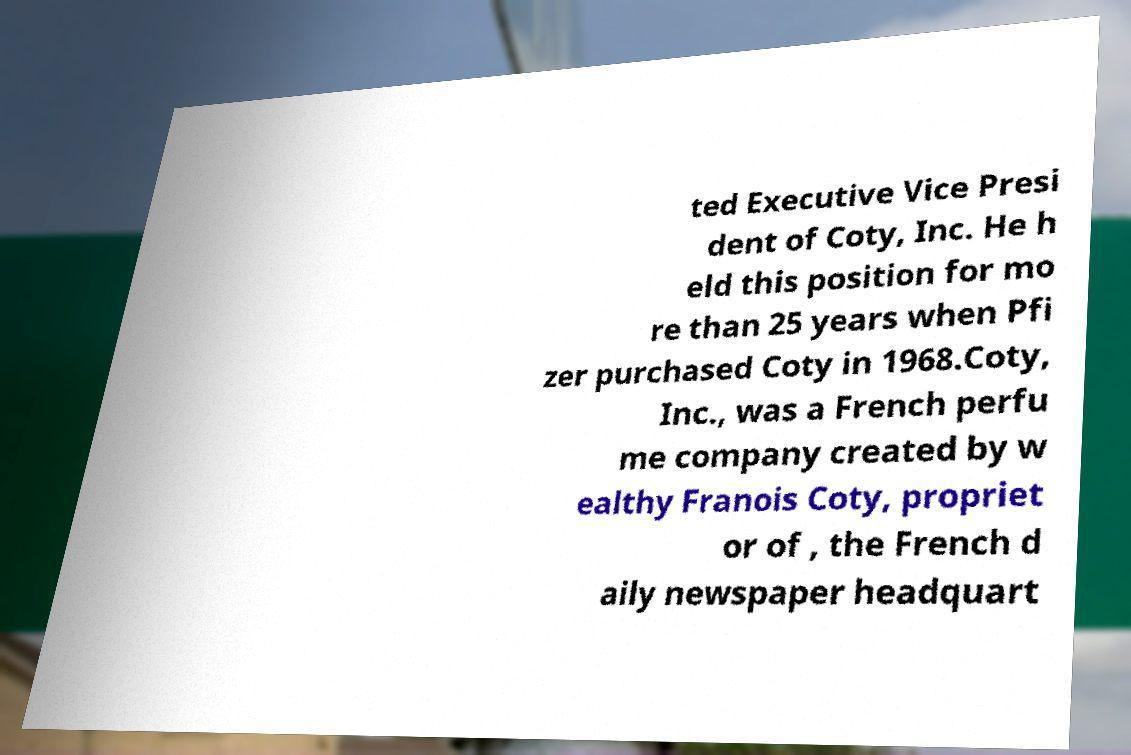Could you extract and type out the text from this image? ted Executive Vice Presi dent of Coty, Inc. He h eld this position for mo re than 25 years when Pfi zer purchased Coty in 1968.Coty, Inc., was a French perfu me company created by w ealthy Franois Coty, propriet or of , the French d aily newspaper headquart 